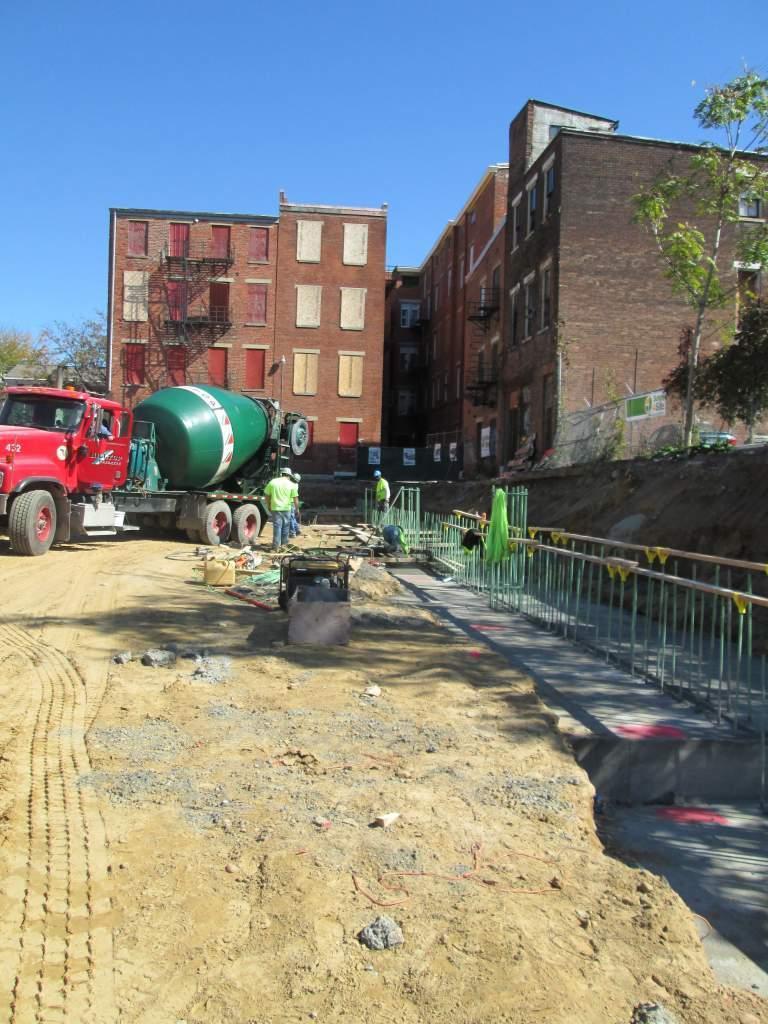Could you give a brief overview of what you see in this image? In this picture there are people in the center of the image and there is a trailer truck on the left side of the image, there is a boundary on the right side of the image, there are buildings in the background area of the image, there are windows on it, there is greenery in the image, there are barrels in the image. 